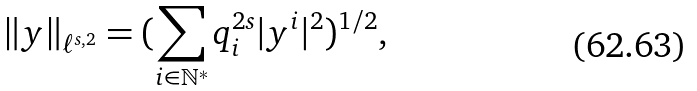<formula> <loc_0><loc_0><loc_500><loc_500>\| y \| _ { \ell ^ { s , 2 } } = ( \sum _ { i \in \mathbb { N } ^ { * } } q _ { i } ^ { 2 s } | y ^ { i } | ^ { 2 } ) ^ { 1 / 2 } ,</formula> 